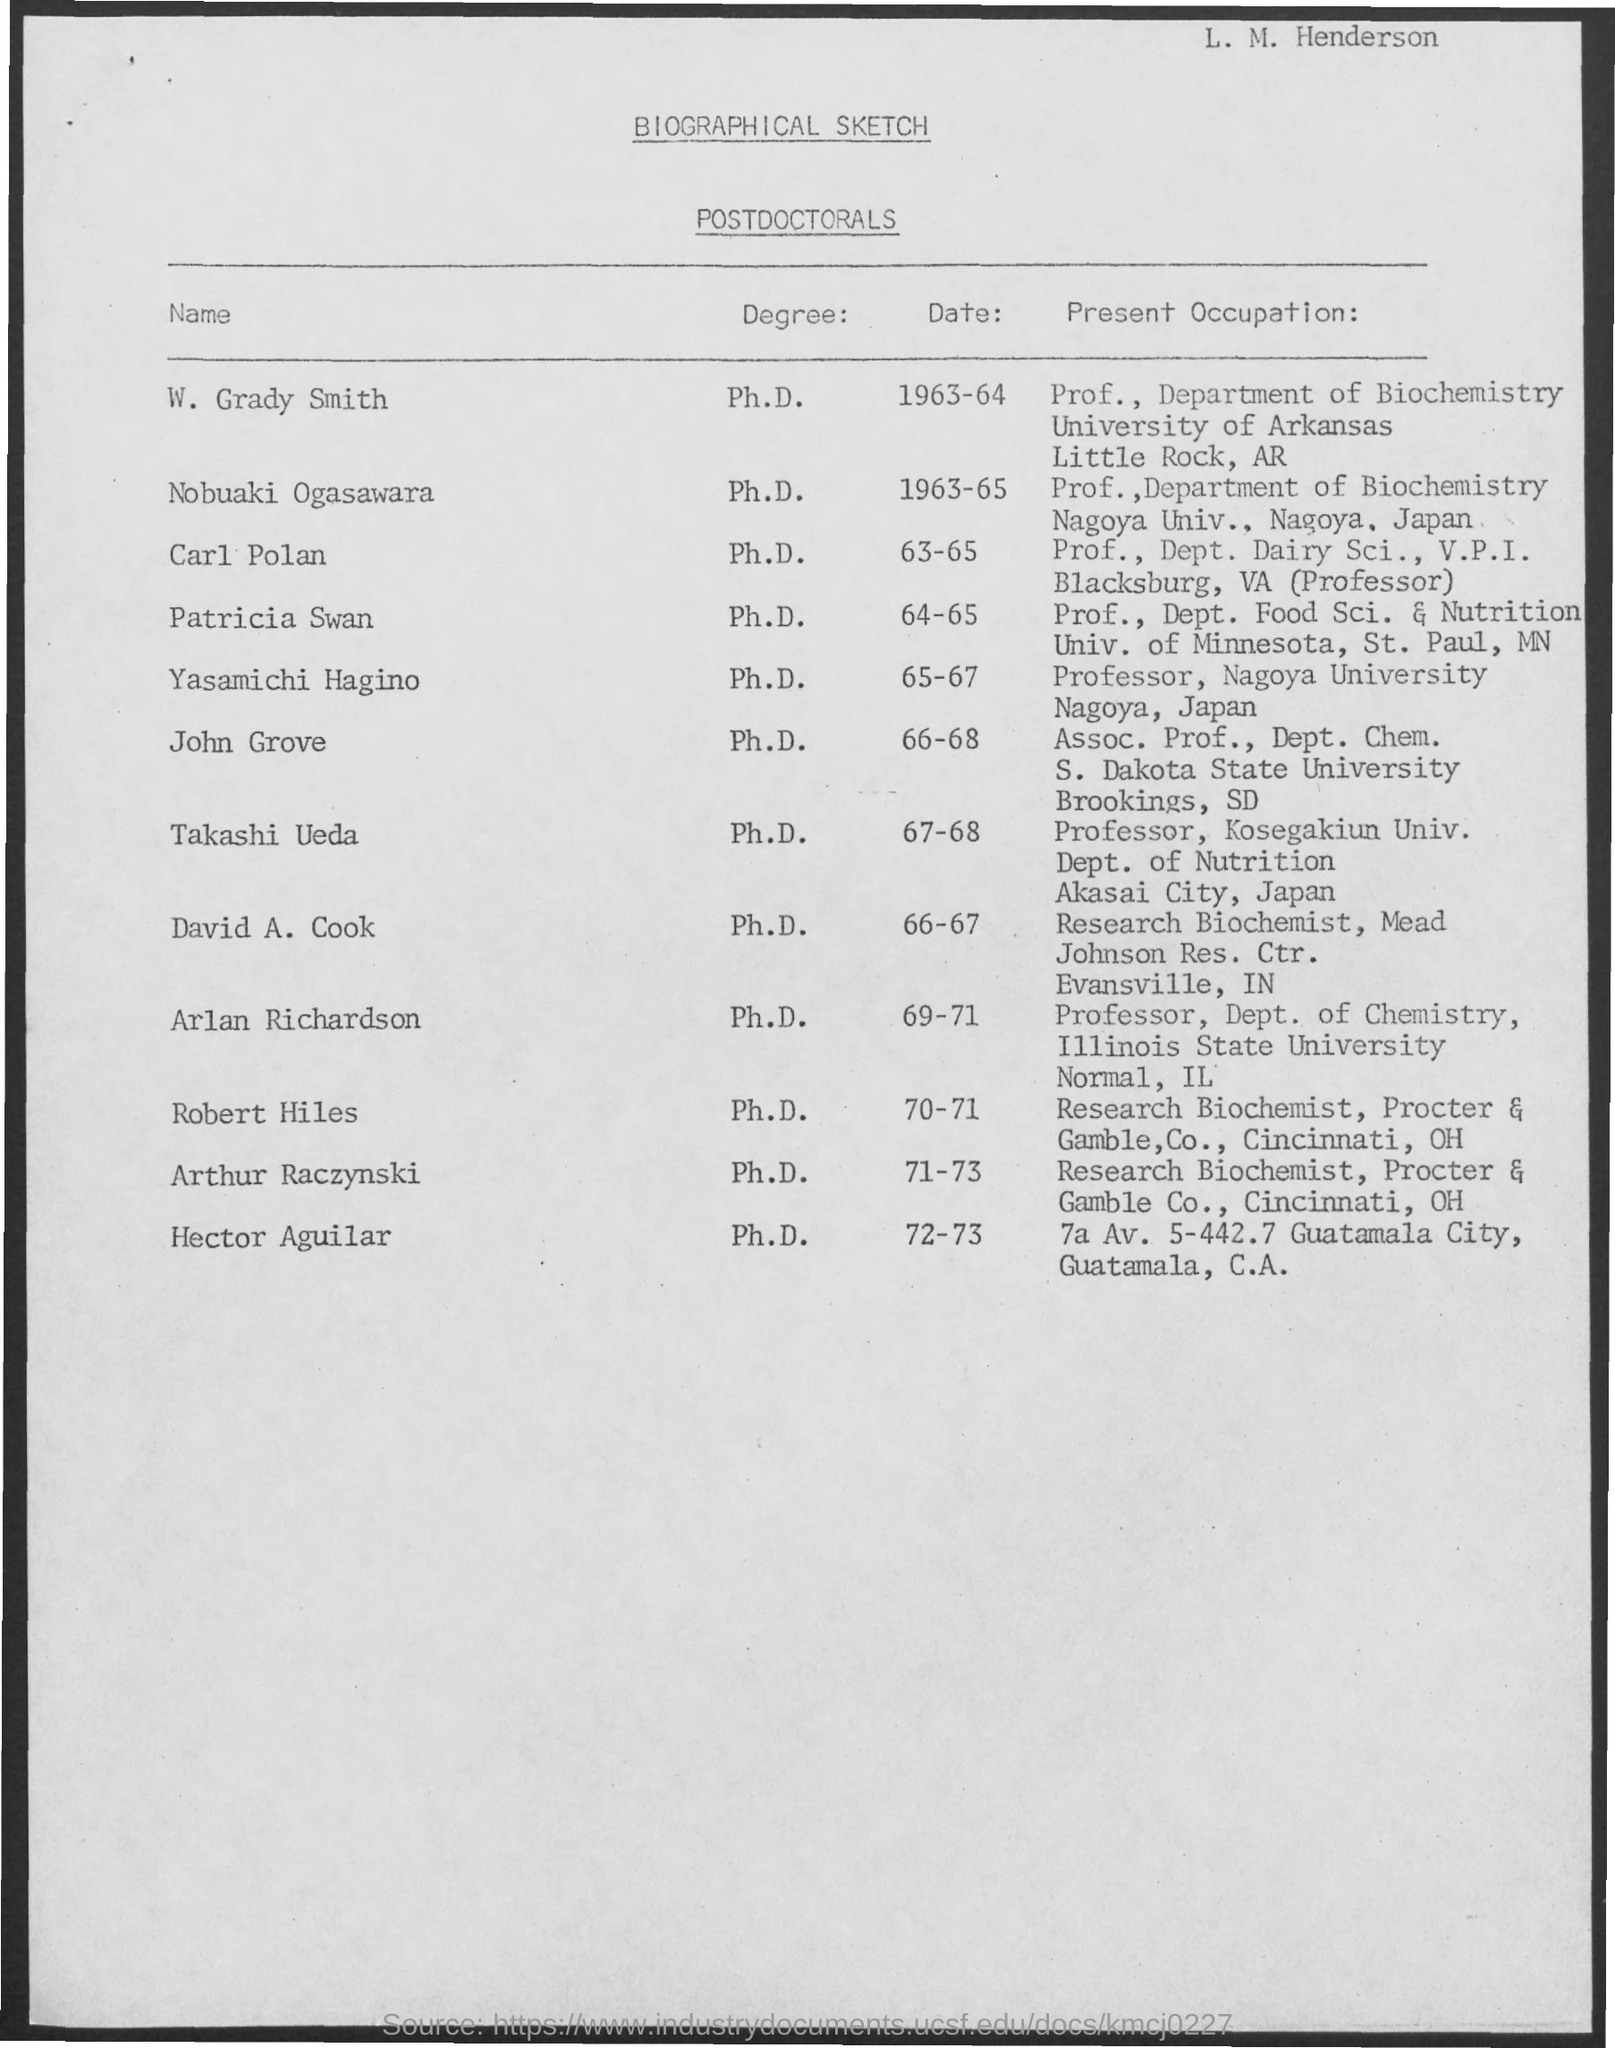Draw attention to some important aspects in this diagram. Dr. W. Grady Smith holds a Ph.D. degree. The title of this document is 'BIOGRAPHICAL SKETCH'. John Grove holds a Ph.D. degree. Nobuaki Ogasawara holds a Ph.D. degree. Patricia Swan holds a Doctor of Philosophy (Ph.D.) degree. 